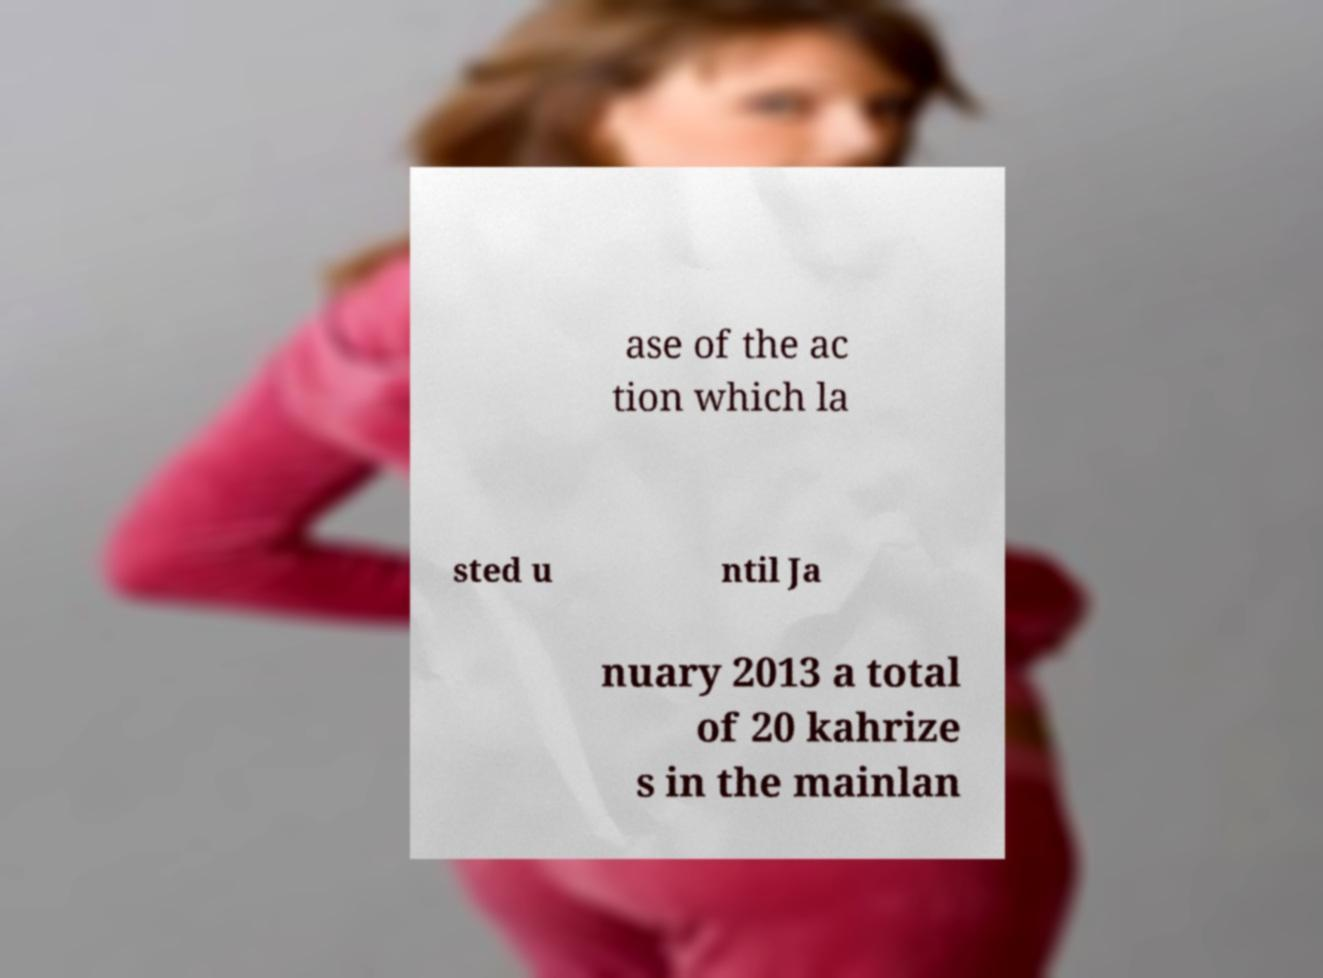Please read and relay the text visible in this image. What does it say? ase of the ac tion which la sted u ntil Ja nuary 2013 a total of 20 kahrize s in the mainlan 